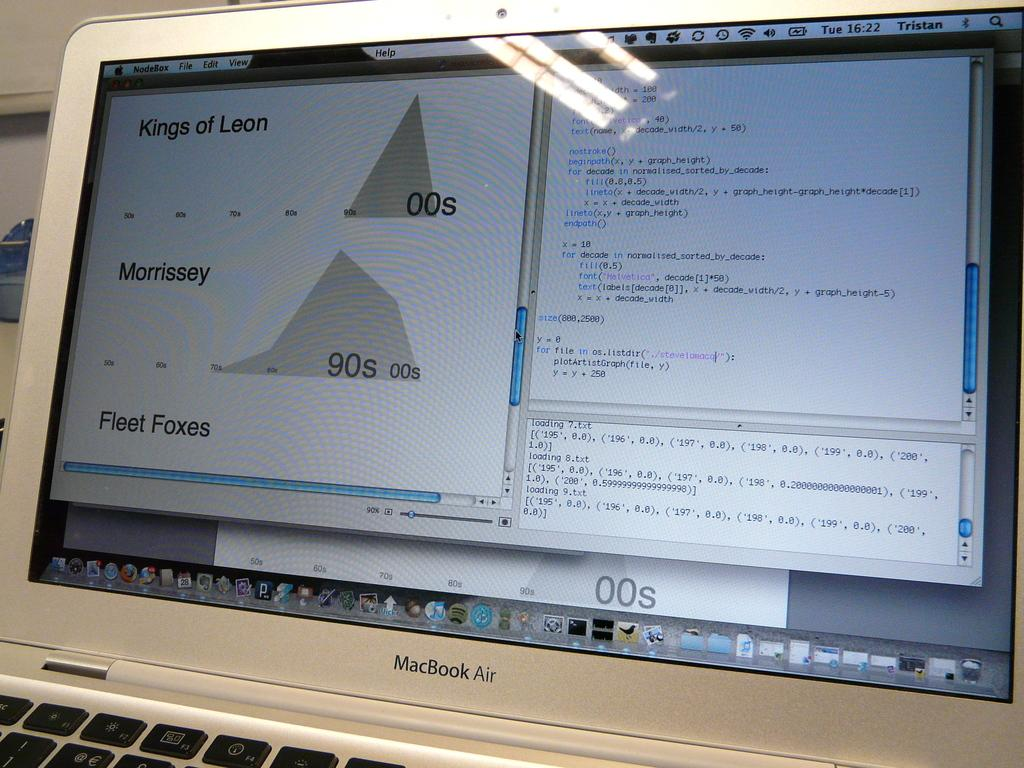<image>
Summarize the visual content of the image. a MacBook Air computer with words Kings of Leon and Morrissey on the monitor 